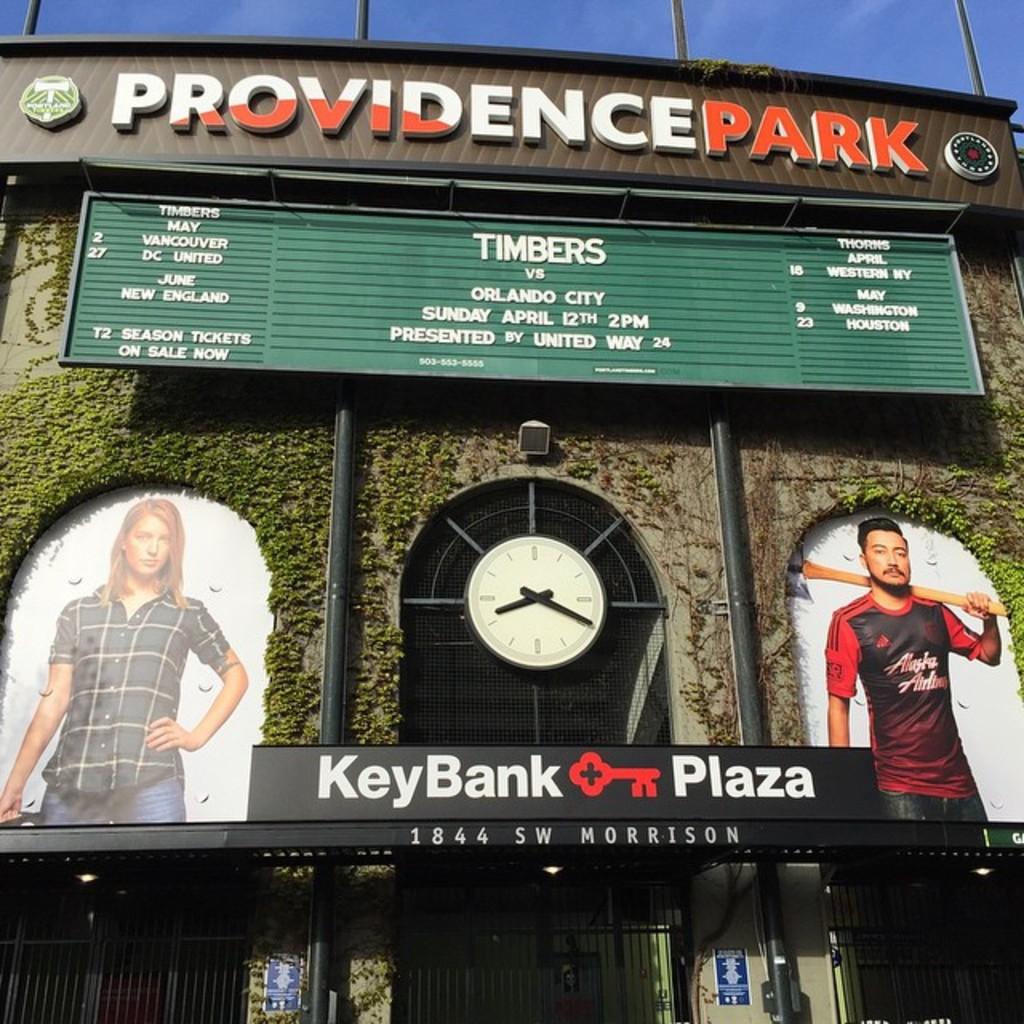Who is playing today?
Provide a succinct answer. Timbers vs orlando city. Where is the providence park located?
Give a very brief answer. 1844 sw morrison. 